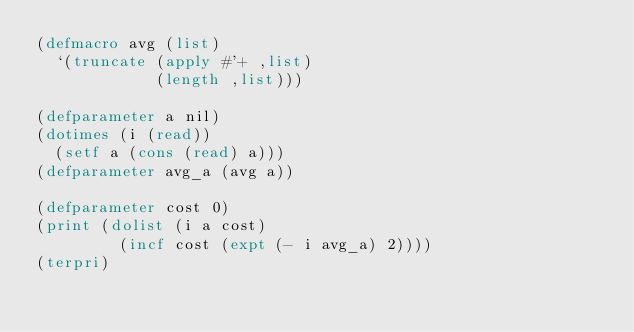Convert code to text. <code><loc_0><loc_0><loc_500><loc_500><_Lisp_>(defmacro avg (list)
  `(truncate (apply #'+ ,list)
             (length ,list)))

(defparameter a nil)
(dotimes (i (read))
  (setf a (cons (read) a)))
(defparameter avg_a (avg a))

(defparameter cost 0)
(print (dolist (i a cost)
         (incf cost (expt (- i avg_a) 2))))
(terpri)
</code> 